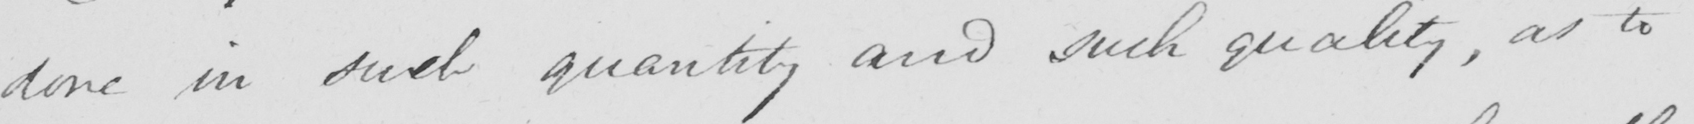Please transcribe the handwritten text in this image. done in such quantity and such quality , as to 